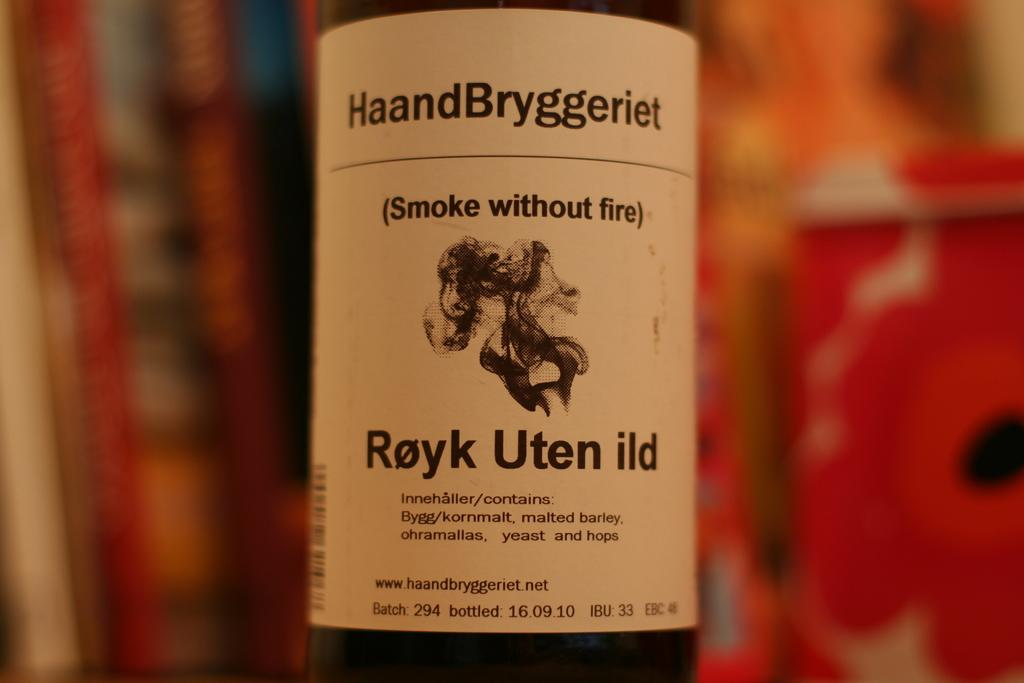<image>
Write a terse but informative summary of the picture. HaandBryggeriet Royk Uten ild smoke without fire bottle. 